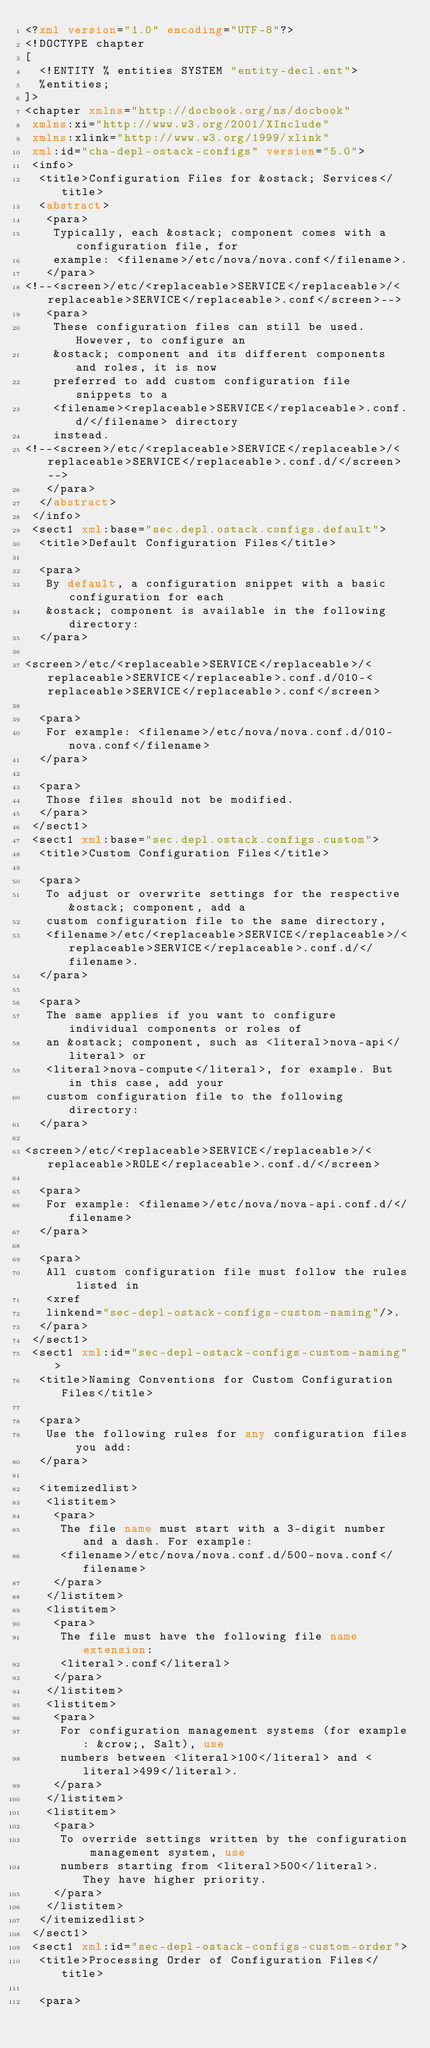<code> <loc_0><loc_0><loc_500><loc_500><_XML_><?xml version="1.0" encoding="UTF-8"?>
<!DOCTYPE chapter
[
  <!ENTITY % entities SYSTEM "entity-decl.ent">
  %entities;
]>
<chapter xmlns="http://docbook.org/ns/docbook"
 xmlns:xi="http://www.w3.org/2001/XInclude"
 xmlns:xlink="http://www.w3.org/1999/xlink"
 xml:id="cha-depl-ostack-configs" version="5.0">
 <info>
  <title>Configuration Files for &ostack; Services</title>
  <abstract>
   <para>
    Typically, each &ostack; component comes with a configuration file, for
    example: <filename>/etc/nova/nova.conf</filename>.
   </para>
<!--<screen>/etc/<replaceable>SERVICE</replaceable>/<replaceable>SERVICE</replaceable>.conf</screen>-->
   <para>
    These configuration files can still be used. However, to configure an
    &ostack; component and its different components and roles, it is now
    preferred to add custom configuration file snippets to a
    <filename><replaceable>SERVICE</replaceable>.conf.d/</filename> directory
    instead.
<!--<screen>/etc/<replaceable>SERVICE</replaceable>/<replaceable>SERVICE</replaceable>.conf.d/</screen>-->
   </para>
  </abstract>
 </info>
 <sect1 xml:base="sec.depl.ostack.configs.default">
  <title>Default Configuration Files</title>

  <para>
   By default, a configuration snippet with a basic configuration for each
   &ostack; component is available in the following directory:
  </para>

<screen>/etc/<replaceable>SERVICE</replaceable>/<replaceable>SERVICE</replaceable>.conf.d/010-<replaceable>SERVICE</replaceable>.conf</screen>

  <para>
   For example: <filename>/etc/nova/nova.conf.d/010-nova.conf</filename>
  </para>

  <para>
   Those files should not be modified.
  </para>
 </sect1>
 <sect1 xml:base="sec.depl.ostack.configs.custom">
  <title>Custom Configuration Files</title>

  <para>
   To adjust or overwrite settings for the respective &ostack; component, add a
   custom configuration file to the same directory,
   <filename>/etc/<replaceable>SERVICE</replaceable>/<replaceable>SERVICE</replaceable>.conf.d/</filename>.
  </para>

  <para>
   The same applies if you want to configure individual components or roles of
   an &ostack; component, such as <literal>nova-api</literal> or
   <literal>nova-compute</literal>, for example. But in this case, add your
   custom configuration file to the following directory:
  </para>

<screen>/etc/<replaceable>SERVICE</replaceable>/<replaceable>ROLE</replaceable>.conf.d/</screen>

  <para>
   For example: <filename>/etc/nova/nova-api.conf.d/</filename>
  </para>

  <para>
   All custom configuration file must follow the rules listed in
   <xref
   linkend="sec-depl-ostack-configs-custom-naming"/>.
  </para>
 </sect1>
 <sect1 xml:id="sec-depl-ostack-configs-custom-naming">
  <title>Naming Conventions for Custom Configuration Files</title>

  <para>
   Use the following rules for any configuration files you add:
  </para>

  <itemizedlist>
   <listitem>
    <para>
     The file name must start with a 3-digit number and a dash. For example:
     <filename>/etc/nova/nova.conf.d/500-nova.conf</filename>
    </para>
   </listitem>
   <listitem>
    <para>
     The file must have the following file name extension:
     <literal>.conf</literal>
    </para>
   </listitem>
   <listitem>
    <para>
     For configuration management systems (for example: &crow;, Salt), use
     numbers between <literal>100</literal> and <literal>499</literal>.
    </para>
   </listitem>
   <listitem>
    <para>
     To override settings written by the configuration management system, use
     numbers starting from <literal>500</literal>. They have higher priority.
    </para>
   </listitem>
  </itemizedlist>
 </sect1>
 <sect1 xml:id="sec-depl-ostack-configs-custom-order">
  <title>Processing Order of Configuration Files</title>

  <para></code> 